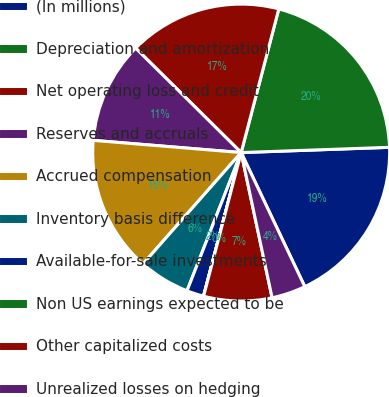Convert chart to OTSL. <chart><loc_0><loc_0><loc_500><loc_500><pie_chart><fcel>(In millions)<fcel>Depreciation and amortization<fcel>Net operating loss and credit<fcel>Reserves and accruals<fcel>Accrued compensation<fcel>Inventory basis difference<fcel>Available-for-sale investments<fcel>Non US earnings expected to be<fcel>Other capitalized costs<fcel>Unrealized losses on hedging<nl><fcel>18.51%<fcel>20.36%<fcel>16.66%<fcel>11.11%<fcel>14.81%<fcel>5.56%<fcel>1.86%<fcel>0.01%<fcel>7.41%<fcel>3.71%<nl></chart> 